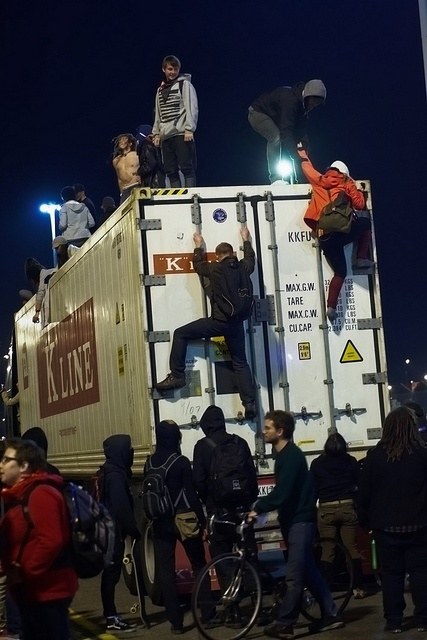Describe the objects in this image and their specific colors. I can see truck in black, lightgray, gray, and olive tones, people in black, maroon, and gray tones, people in black, gray, darkgray, and darkgreen tones, bicycle in black, gray, and darkgray tones, and people in black, gray, and darkgray tones in this image. 